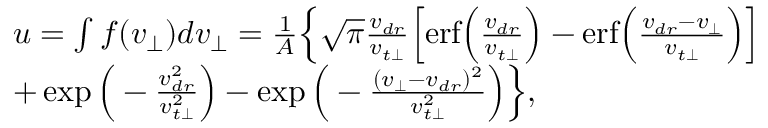<formula> <loc_0><loc_0><loc_500><loc_500>\begin{array} { r l } & { u = \int f ( v _ { \perp } ) d v _ { \perp } = \frac { 1 } { A } \left \{ \sqrt { \pi } \frac { v _ { d r } } { v _ { t \perp } } \left [ e r f \left ( \frac { v _ { d r } } { v _ { t \perp } } \right ) - e r f \left ( \frac { v _ { d r } - v _ { \perp } } { v _ { t \perp } } \right ) \right ] } \\ & { + \exp \left ( - \frac { v _ { d r } ^ { 2 } } { v _ { t \perp } ^ { 2 } } \right ) - \exp \left ( - \frac { ( v _ { \perp } - v _ { d r } ) ^ { 2 } } { v _ { t \perp } ^ { 2 } } \right ) \right \} , } \end{array}</formula> 